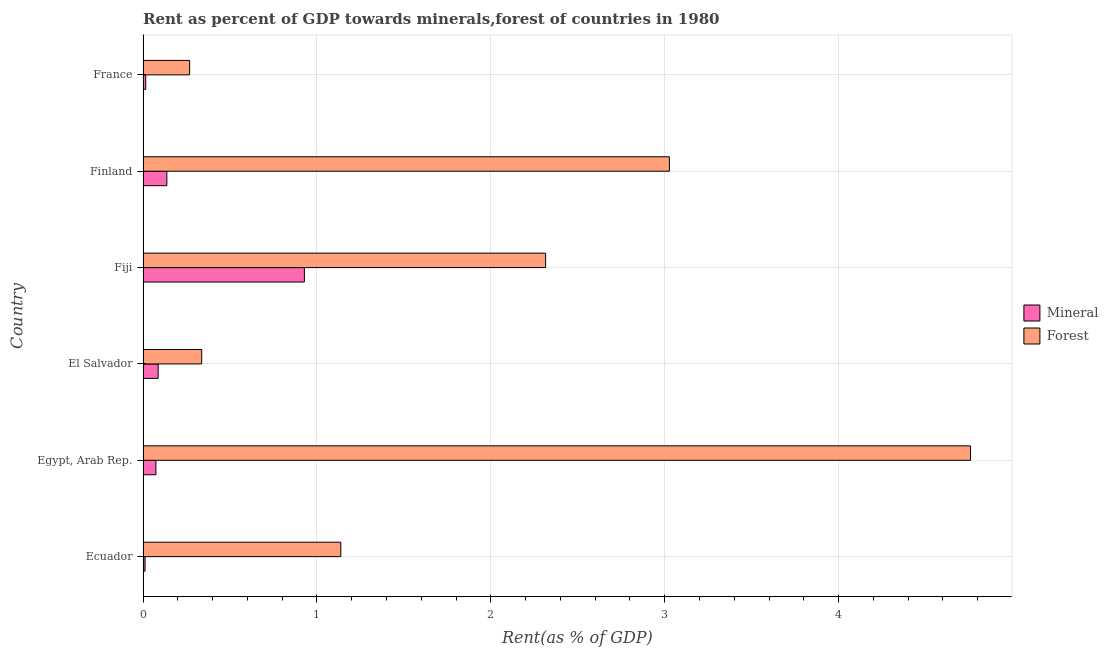How many groups of bars are there?
Offer a very short reply. 6. Are the number of bars per tick equal to the number of legend labels?
Make the answer very short. Yes. Are the number of bars on each tick of the Y-axis equal?
Your response must be concise. Yes. How many bars are there on the 5th tick from the top?
Ensure brevity in your answer.  2. What is the label of the 2nd group of bars from the top?
Keep it short and to the point. Finland. What is the mineral rent in El Salvador?
Offer a very short reply. 0.09. Across all countries, what is the maximum mineral rent?
Your answer should be compact. 0.93. Across all countries, what is the minimum forest rent?
Provide a short and direct response. 0.27. In which country was the forest rent maximum?
Provide a short and direct response. Egypt, Arab Rep. In which country was the mineral rent minimum?
Ensure brevity in your answer.  Ecuador. What is the total forest rent in the graph?
Provide a succinct answer. 11.84. What is the difference between the mineral rent in Ecuador and that in El Salvador?
Make the answer very short. -0.07. What is the difference between the forest rent in Ecuador and the mineral rent in France?
Your answer should be very brief. 1.12. What is the average forest rent per country?
Your answer should be very brief. 1.97. What is the difference between the forest rent and mineral rent in Finland?
Make the answer very short. 2.89. What is the ratio of the mineral rent in Egypt, Arab Rep. to that in El Salvador?
Offer a terse response. 0.85. What is the difference between the highest and the second highest mineral rent?
Provide a short and direct response. 0.79. What is the difference between the highest and the lowest mineral rent?
Offer a terse response. 0.92. What does the 2nd bar from the top in Finland represents?
Your response must be concise. Mineral. What does the 2nd bar from the bottom in El Salvador represents?
Your response must be concise. Forest. Are all the bars in the graph horizontal?
Provide a short and direct response. Yes. What is the difference between two consecutive major ticks on the X-axis?
Keep it short and to the point. 1. Does the graph contain grids?
Your answer should be very brief. Yes. Where does the legend appear in the graph?
Provide a succinct answer. Center right. How many legend labels are there?
Your answer should be compact. 2. How are the legend labels stacked?
Ensure brevity in your answer.  Vertical. What is the title of the graph?
Ensure brevity in your answer.  Rent as percent of GDP towards minerals,forest of countries in 1980. What is the label or title of the X-axis?
Provide a succinct answer. Rent(as % of GDP). What is the label or title of the Y-axis?
Ensure brevity in your answer.  Country. What is the Rent(as % of GDP) of Mineral in Ecuador?
Ensure brevity in your answer.  0.01. What is the Rent(as % of GDP) of Forest in Ecuador?
Your answer should be compact. 1.14. What is the Rent(as % of GDP) of Mineral in Egypt, Arab Rep.?
Keep it short and to the point. 0.07. What is the Rent(as % of GDP) in Forest in Egypt, Arab Rep.?
Make the answer very short. 4.76. What is the Rent(as % of GDP) in Mineral in El Salvador?
Keep it short and to the point. 0.09. What is the Rent(as % of GDP) in Forest in El Salvador?
Your answer should be compact. 0.34. What is the Rent(as % of GDP) in Mineral in Fiji?
Provide a short and direct response. 0.93. What is the Rent(as % of GDP) in Forest in Fiji?
Provide a succinct answer. 2.31. What is the Rent(as % of GDP) in Mineral in Finland?
Your answer should be very brief. 0.14. What is the Rent(as % of GDP) in Forest in Finland?
Your answer should be compact. 3.03. What is the Rent(as % of GDP) of Mineral in France?
Your response must be concise. 0.02. What is the Rent(as % of GDP) in Forest in France?
Provide a succinct answer. 0.27. Across all countries, what is the maximum Rent(as % of GDP) of Mineral?
Offer a terse response. 0.93. Across all countries, what is the maximum Rent(as % of GDP) in Forest?
Your answer should be very brief. 4.76. Across all countries, what is the minimum Rent(as % of GDP) in Mineral?
Make the answer very short. 0.01. Across all countries, what is the minimum Rent(as % of GDP) of Forest?
Offer a terse response. 0.27. What is the total Rent(as % of GDP) of Mineral in the graph?
Give a very brief answer. 1.25. What is the total Rent(as % of GDP) of Forest in the graph?
Provide a succinct answer. 11.84. What is the difference between the Rent(as % of GDP) in Mineral in Ecuador and that in Egypt, Arab Rep.?
Offer a terse response. -0.06. What is the difference between the Rent(as % of GDP) of Forest in Ecuador and that in Egypt, Arab Rep.?
Provide a short and direct response. -3.62. What is the difference between the Rent(as % of GDP) of Mineral in Ecuador and that in El Salvador?
Provide a succinct answer. -0.08. What is the difference between the Rent(as % of GDP) of Forest in Ecuador and that in El Salvador?
Your answer should be very brief. 0.8. What is the difference between the Rent(as % of GDP) of Mineral in Ecuador and that in Fiji?
Provide a short and direct response. -0.92. What is the difference between the Rent(as % of GDP) in Forest in Ecuador and that in Fiji?
Give a very brief answer. -1.18. What is the difference between the Rent(as % of GDP) in Mineral in Ecuador and that in Finland?
Offer a very short reply. -0.13. What is the difference between the Rent(as % of GDP) of Forest in Ecuador and that in Finland?
Your answer should be very brief. -1.89. What is the difference between the Rent(as % of GDP) of Mineral in Ecuador and that in France?
Provide a short and direct response. -0. What is the difference between the Rent(as % of GDP) of Forest in Ecuador and that in France?
Your answer should be compact. 0.87. What is the difference between the Rent(as % of GDP) of Mineral in Egypt, Arab Rep. and that in El Salvador?
Keep it short and to the point. -0.01. What is the difference between the Rent(as % of GDP) in Forest in Egypt, Arab Rep. and that in El Salvador?
Provide a succinct answer. 4.42. What is the difference between the Rent(as % of GDP) in Mineral in Egypt, Arab Rep. and that in Fiji?
Ensure brevity in your answer.  -0.85. What is the difference between the Rent(as % of GDP) of Forest in Egypt, Arab Rep. and that in Fiji?
Your response must be concise. 2.44. What is the difference between the Rent(as % of GDP) of Mineral in Egypt, Arab Rep. and that in Finland?
Your answer should be very brief. -0.06. What is the difference between the Rent(as % of GDP) in Forest in Egypt, Arab Rep. and that in Finland?
Provide a short and direct response. 1.73. What is the difference between the Rent(as % of GDP) of Mineral in Egypt, Arab Rep. and that in France?
Offer a terse response. 0.06. What is the difference between the Rent(as % of GDP) in Forest in Egypt, Arab Rep. and that in France?
Make the answer very short. 4.49. What is the difference between the Rent(as % of GDP) in Mineral in El Salvador and that in Fiji?
Your response must be concise. -0.84. What is the difference between the Rent(as % of GDP) in Forest in El Salvador and that in Fiji?
Provide a short and direct response. -1.98. What is the difference between the Rent(as % of GDP) in Forest in El Salvador and that in Finland?
Offer a very short reply. -2.69. What is the difference between the Rent(as % of GDP) of Mineral in El Salvador and that in France?
Provide a succinct answer. 0.07. What is the difference between the Rent(as % of GDP) of Forest in El Salvador and that in France?
Offer a very short reply. 0.07. What is the difference between the Rent(as % of GDP) of Mineral in Fiji and that in Finland?
Ensure brevity in your answer.  0.79. What is the difference between the Rent(as % of GDP) in Forest in Fiji and that in Finland?
Your answer should be very brief. -0.71. What is the difference between the Rent(as % of GDP) of Mineral in Fiji and that in France?
Ensure brevity in your answer.  0.91. What is the difference between the Rent(as % of GDP) in Forest in Fiji and that in France?
Offer a very short reply. 2.05. What is the difference between the Rent(as % of GDP) of Mineral in Finland and that in France?
Your answer should be compact. 0.12. What is the difference between the Rent(as % of GDP) of Forest in Finland and that in France?
Offer a very short reply. 2.76. What is the difference between the Rent(as % of GDP) of Mineral in Ecuador and the Rent(as % of GDP) of Forest in Egypt, Arab Rep.?
Your response must be concise. -4.75. What is the difference between the Rent(as % of GDP) in Mineral in Ecuador and the Rent(as % of GDP) in Forest in El Salvador?
Offer a very short reply. -0.33. What is the difference between the Rent(as % of GDP) of Mineral in Ecuador and the Rent(as % of GDP) of Forest in Fiji?
Offer a very short reply. -2.3. What is the difference between the Rent(as % of GDP) in Mineral in Ecuador and the Rent(as % of GDP) in Forest in Finland?
Provide a short and direct response. -3.02. What is the difference between the Rent(as % of GDP) in Mineral in Ecuador and the Rent(as % of GDP) in Forest in France?
Offer a very short reply. -0.26. What is the difference between the Rent(as % of GDP) in Mineral in Egypt, Arab Rep. and the Rent(as % of GDP) in Forest in El Salvador?
Keep it short and to the point. -0.26. What is the difference between the Rent(as % of GDP) of Mineral in Egypt, Arab Rep. and the Rent(as % of GDP) of Forest in Fiji?
Offer a terse response. -2.24. What is the difference between the Rent(as % of GDP) of Mineral in Egypt, Arab Rep. and the Rent(as % of GDP) of Forest in Finland?
Offer a very short reply. -2.95. What is the difference between the Rent(as % of GDP) in Mineral in Egypt, Arab Rep. and the Rent(as % of GDP) in Forest in France?
Your response must be concise. -0.19. What is the difference between the Rent(as % of GDP) of Mineral in El Salvador and the Rent(as % of GDP) of Forest in Fiji?
Give a very brief answer. -2.23. What is the difference between the Rent(as % of GDP) of Mineral in El Salvador and the Rent(as % of GDP) of Forest in Finland?
Your response must be concise. -2.94. What is the difference between the Rent(as % of GDP) in Mineral in El Salvador and the Rent(as % of GDP) in Forest in France?
Provide a short and direct response. -0.18. What is the difference between the Rent(as % of GDP) in Mineral in Fiji and the Rent(as % of GDP) in Forest in Finland?
Offer a very short reply. -2.1. What is the difference between the Rent(as % of GDP) in Mineral in Fiji and the Rent(as % of GDP) in Forest in France?
Provide a succinct answer. 0.66. What is the difference between the Rent(as % of GDP) in Mineral in Finland and the Rent(as % of GDP) in Forest in France?
Offer a terse response. -0.13. What is the average Rent(as % of GDP) of Mineral per country?
Keep it short and to the point. 0.21. What is the average Rent(as % of GDP) of Forest per country?
Provide a short and direct response. 1.97. What is the difference between the Rent(as % of GDP) in Mineral and Rent(as % of GDP) in Forest in Ecuador?
Offer a terse response. -1.13. What is the difference between the Rent(as % of GDP) in Mineral and Rent(as % of GDP) in Forest in Egypt, Arab Rep.?
Your response must be concise. -4.68. What is the difference between the Rent(as % of GDP) of Mineral and Rent(as % of GDP) of Forest in El Salvador?
Offer a terse response. -0.25. What is the difference between the Rent(as % of GDP) in Mineral and Rent(as % of GDP) in Forest in Fiji?
Keep it short and to the point. -1.39. What is the difference between the Rent(as % of GDP) in Mineral and Rent(as % of GDP) in Forest in Finland?
Your answer should be compact. -2.89. What is the difference between the Rent(as % of GDP) in Mineral and Rent(as % of GDP) in Forest in France?
Offer a terse response. -0.25. What is the ratio of the Rent(as % of GDP) in Mineral in Ecuador to that in Egypt, Arab Rep.?
Make the answer very short. 0.16. What is the ratio of the Rent(as % of GDP) of Forest in Ecuador to that in Egypt, Arab Rep.?
Your response must be concise. 0.24. What is the ratio of the Rent(as % of GDP) of Mineral in Ecuador to that in El Salvador?
Your response must be concise. 0.13. What is the ratio of the Rent(as % of GDP) in Forest in Ecuador to that in El Salvador?
Keep it short and to the point. 3.37. What is the ratio of the Rent(as % of GDP) in Mineral in Ecuador to that in Fiji?
Ensure brevity in your answer.  0.01. What is the ratio of the Rent(as % of GDP) of Forest in Ecuador to that in Fiji?
Make the answer very short. 0.49. What is the ratio of the Rent(as % of GDP) in Mineral in Ecuador to that in Finland?
Give a very brief answer. 0.08. What is the ratio of the Rent(as % of GDP) in Forest in Ecuador to that in Finland?
Your answer should be compact. 0.38. What is the ratio of the Rent(as % of GDP) in Mineral in Ecuador to that in France?
Make the answer very short. 0.75. What is the ratio of the Rent(as % of GDP) of Forest in Ecuador to that in France?
Your answer should be compact. 4.25. What is the ratio of the Rent(as % of GDP) of Mineral in Egypt, Arab Rep. to that in El Salvador?
Your answer should be compact. 0.85. What is the ratio of the Rent(as % of GDP) of Forest in Egypt, Arab Rep. to that in El Salvador?
Your answer should be very brief. 14.11. What is the ratio of the Rent(as % of GDP) of Mineral in Egypt, Arab Rep. to that in Fiji?
Give a very brief answer. 0.08. What is the ratio of the Rent(as % of GDP) of Forest in Egypt, Arab Rep. to that in Fiji?
Offer a very short reply. 2.06. What is the ratio of the Rent(as % of GDP) in Mineral in Egypt, Arab Rep. to that in Finland?
Keep it short and to the point. 0.54. What is the ratio of the Rent(as % of GDP) of Forest in Egypt, Arab Rep. to that in Finland?
Offer a terse response. 1.57. What is the ratio of the Rent(as % of GDP) in Mineral in Egypt, Arab Rep. to that in France?
Give a very brief answer. 4.81. What is the ratio of the Rent(as % of GDP) in Forest in Egypt, Arab Rep. to that in France?
Keep it short and to the point. 17.78. What is the ratio of the Rent(as % of GDP) of Mineral in El Salvador to that in Fiji?
Your answer should be compact. 0.09. What is the ratio of the Rent(as % of GDP) of Forest in El Salvador to that in Fiji?
Provide a succinct answer. 0.15. What is the ratio of the Rent(as % of GDP) of Mineral in El Salvador to that in Finland?
Give a very brief answer. 0.63. What is the ratio of the Rent(as % of GDP) of Forest in El Salvador to that in Finland?
Provide a short and direct response. 0.11. What is the ratio of the Rent(as % of GDP) of Mineral in El Salvador to that in France?
Your answer should be compact. 5.65. What is the ratio of the Rent(as % of GDP) in Forest in El Salvador to that in France?
Offer a very short reply. 1.26. What is the ratio of the Rent(as % of GDP) of Mineral in Fiji to that in Finland?
Your answer should be compact. 6.78. What is the ratio of the Rent(as % of GDP) in Forest in Fiji to that in Finland?
Make the answer very short. 0.76. What is the ratio of the Rent(as % of GDP) of Mineral in Fiji to that in France?
Your response must be concise. 60.38. What is the ratio of the Rent(as % of GDP) of Forest in Fiji to that in France?
Provide a short and direct response. 8.65. What is the ratio of the Rent(as % of GDP) of Mineral in Finland to that in France?
Offer a very short reply. 8.9. What is the ratio of the Rent(as % of GDP) in Forest in Finland to that in France?
Keep it short and to the point. 11.31. What is the difference between the highest and the second highest Rent(as % of GDP) in Mineral?
Provide a succinct answer. 0.79. What is the difference between the highest and the second highest Rent(as % of GDP) of Forest?
Provide a succinct answer. 1.73. What is the difference between the highest and the lowest Rent(as % of GDP) of Mineral?
Your answer should be very brief. 0.92. What is the difference between the highest and the lowest Rent(as % of GDP) in Forest?
Provide a succinct answer. 4.49. 